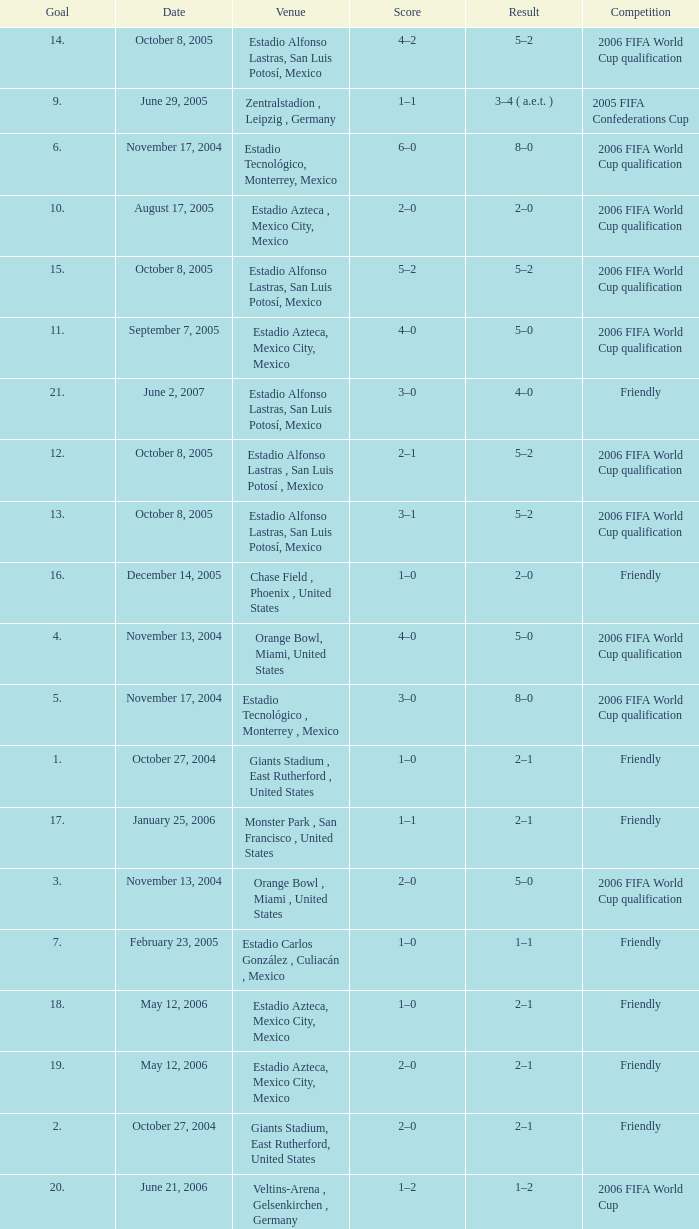Which Score has a Result of 2–1, and a Competition of friendly, and a Goal smaller than 17? 1–0, 2–0. 